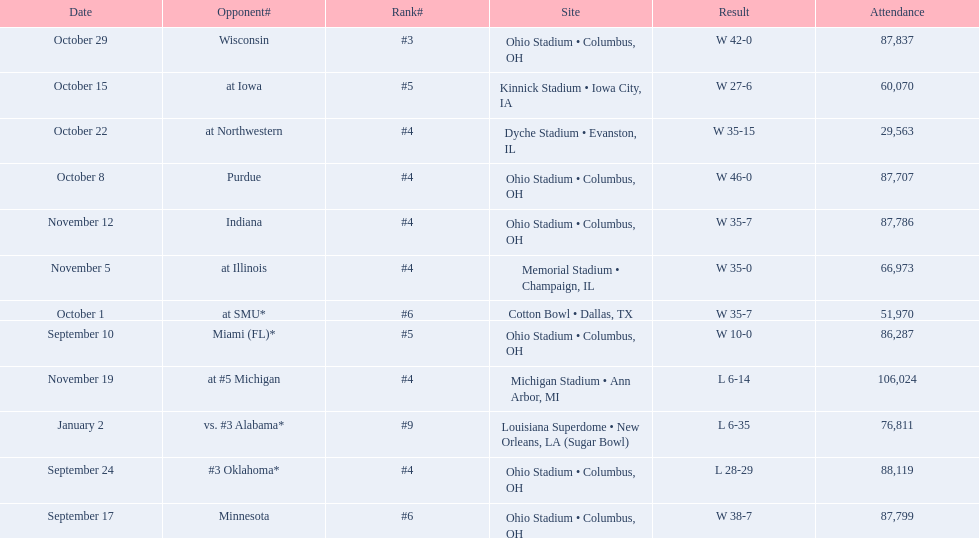In how many games did the attendance exceed 80,000 people? 7. 